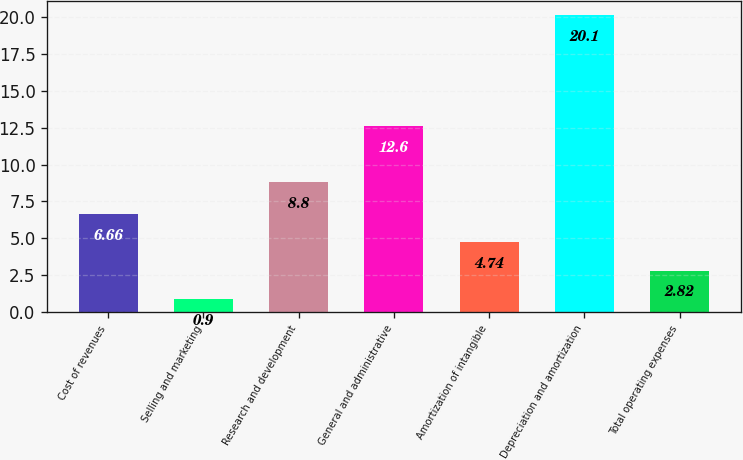Convert chart to OTSL. <chart><loc_0><loc_0><loc_500><loc_500><bar_chart><fcel>Cost of revenues<fcel>Selling and marketing<fcel>Research and development<fcel>General and administrative<fcel>Amortization of intangible<fcel>Depreciation and amortization<fcel>Total operating expenses<nl><fcel>6.66<fcel>0.9<fcel>8.8<fcel>12.6<fcel>4.74<fcel>20.1<fcel>2.82<nl></chart> 